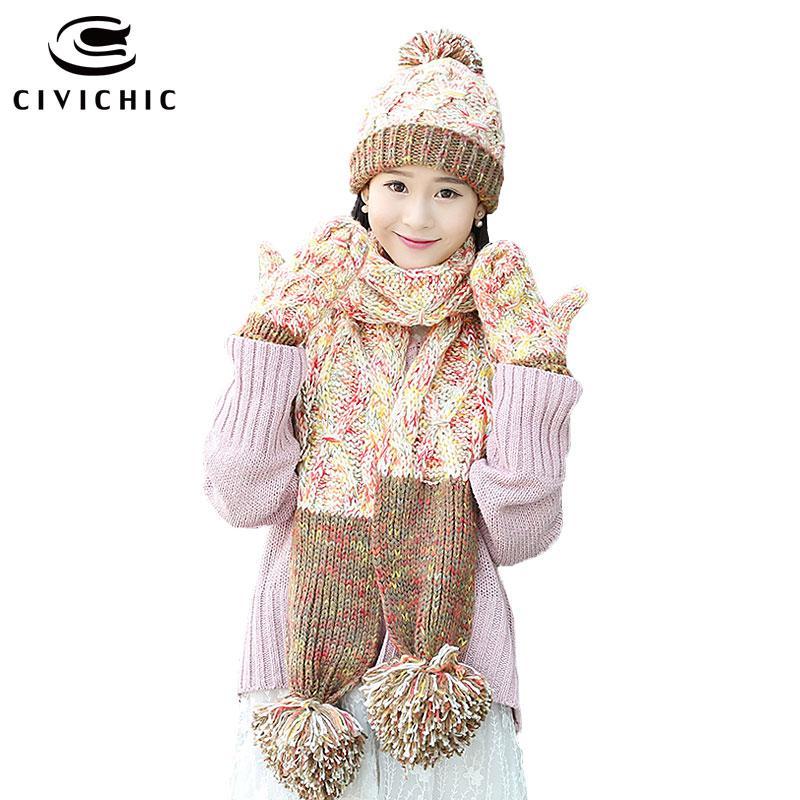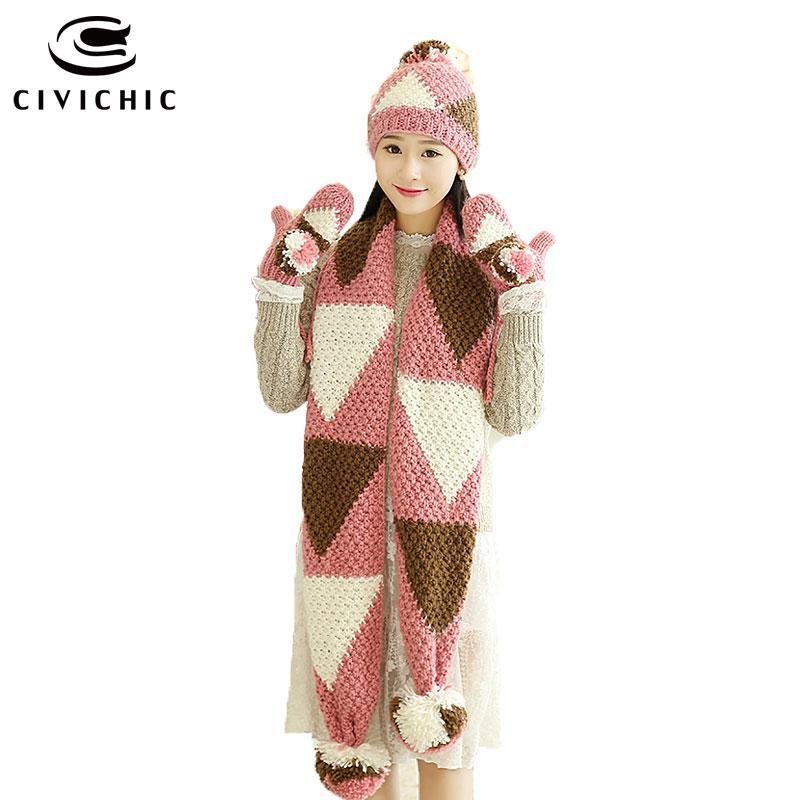The first image is the image on the left, the second image is the image on the right. Given the left and right images, does the statement "Both women are wearing hats with pom poms." hold true? Answer yes or no. Yes. The first image is the image on the left, the second image is the image on the right. Given the left and right images, does the statement "In one image, a girl is wearing matching hat, mittens and scarf, into which a stripe design has been knitted, with one long end of the scarf draped in front of her." hold true? Answer yes or no. No. 